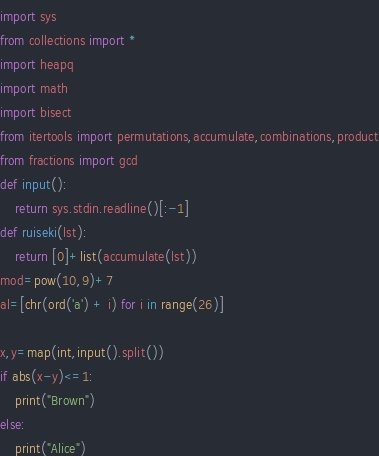<code> <loc_0><loc_0><loc_500><loc_500><_Python_>import sys
from collections import *
import heapq
import math
import bisect
from itertools import permutations,accumulate,combinations,product
from fractions import gcd
def input():
    return sys.stdin.readline()[:-1]
def ruiseki(lst):
    return [0]+list(accumulate(lst))
mod=pow(10,9)+7
al=[chr(ord('a') + i) for i in range(26)]

x,y=map(int,input().split())
if abs(x-y)<=1:
    print("Brown")
else:
    print("Alice")</code> 